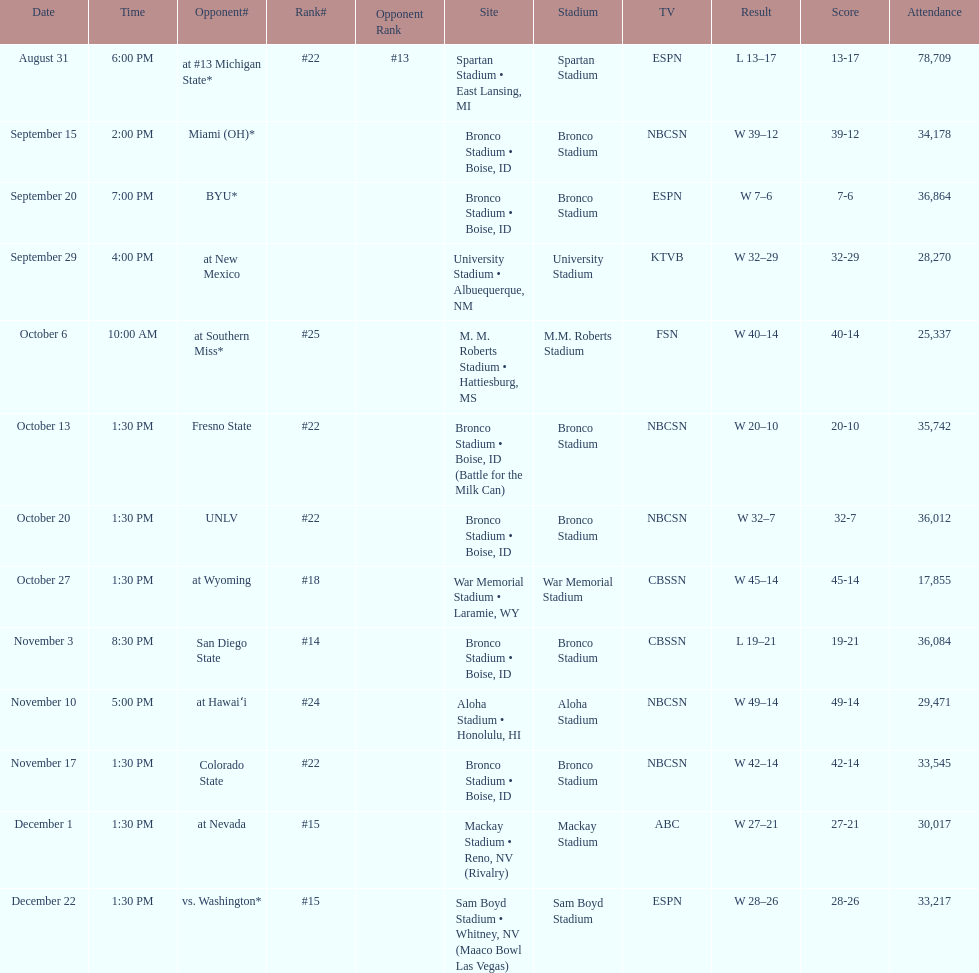Add up the total number of points scored in the last wins for boise state. 146. 